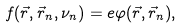<formula> <loc_0><loc_0><loc_500><loc_500>f ( \vec { r } , \vec { r } _ { n } , \nu _ { n } ) = e \varphi ( \vec { r } , \vec { r } _ { n } ) ,</formula> 